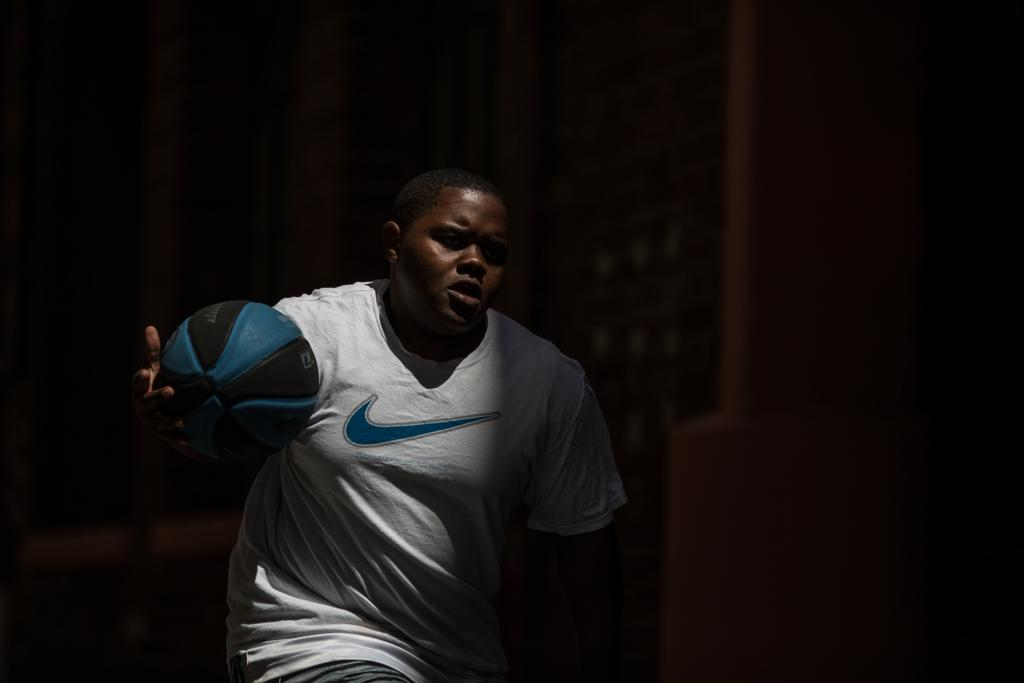Who is the main subject in the image? There is a boy in the image. Where is the boy positioned in the image? The boy is at the center of the image. What is the boy holding in his hand? The boy is holding a ball in his hand. What type of plantation can be seen in the background of the image? There is no plantation present in the image; it only features a boy holding a ball. What kind of bird is sitting on the boy's shoulder in the image? There is no bird, specifically a wren, present in the image. 